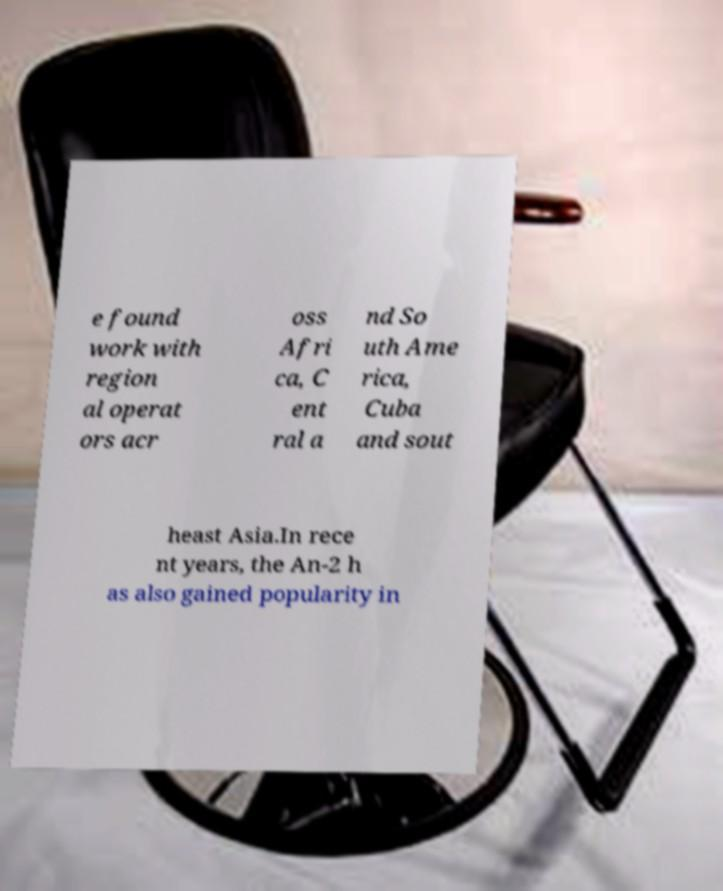What messages or text are displayed in this image? I need them in a readable, typed format. e found work with region al operat ors acr oss Afri ca, C ent ral a nd So uth Ame rica, Cuba and sout heast Asia.In rece nt years, the An-2 h as also gained popularity in 